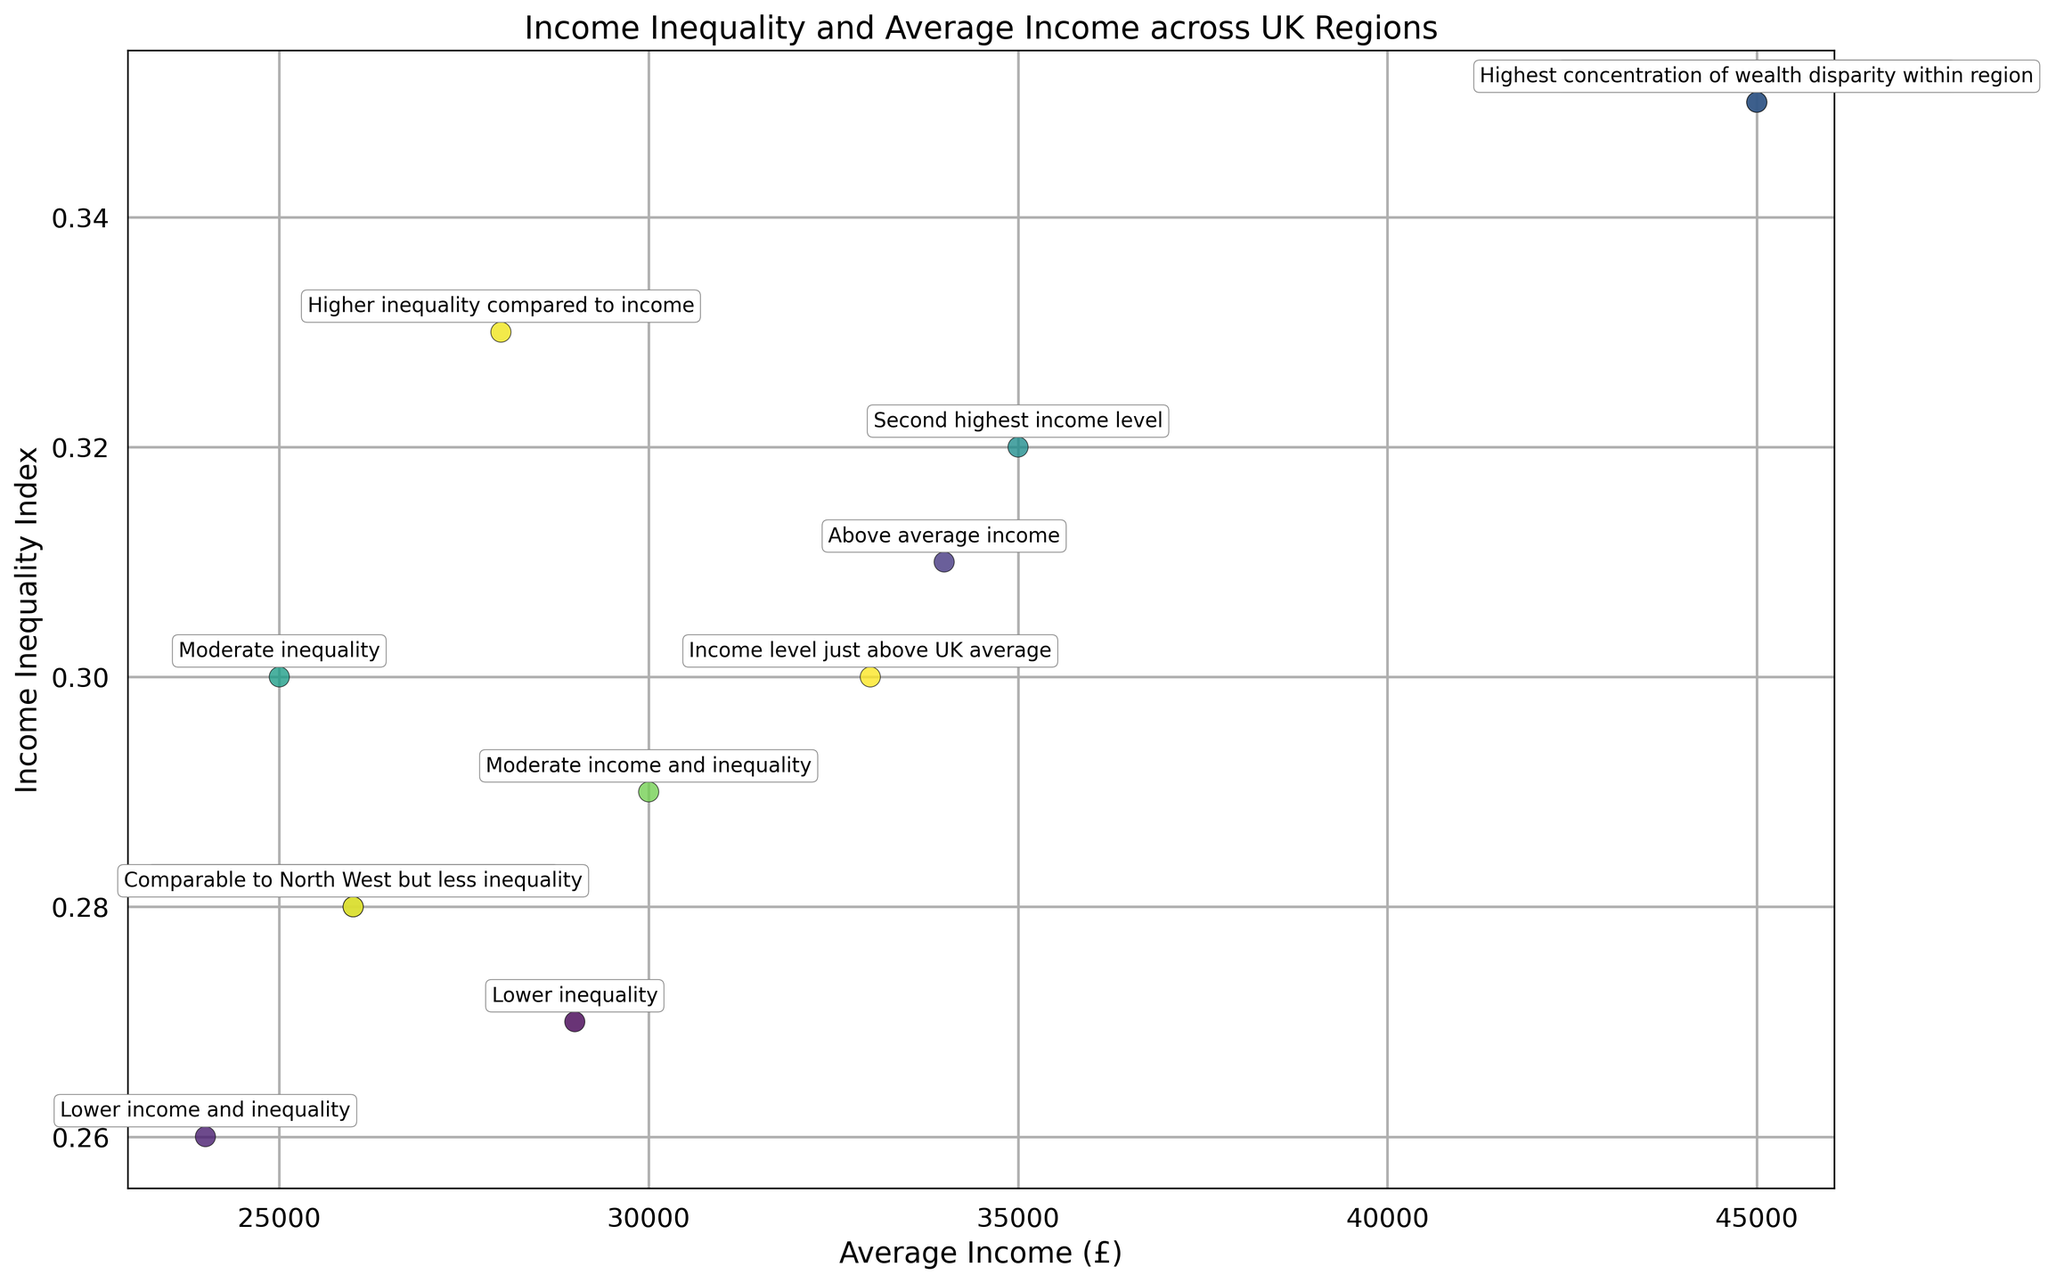Which region has the highest average income? From the scatter plot, we see that London has the highest average income, as annotated with "Highest income and income inequality."
Answer: London Which region has the lowest income inequality index? By examining the scatter plot and annotations, the North East has the lowest income inequality index with a value of 0.26 as noted with "Lower income and inequality."
Answer: North East Compare the average incomes of the South East and the East of England. Which one is higher and by how much? The South East has an average income of £35,000, while the East of England has £34,000. The difference is £35,000 - £34,000 = £1,000.
Answer: South East by £1,000 Is there a region with higher income but lower inequality than the South West? If so, which region? The South West has an average income of £33,000 and an income inequality index of 0.30. The East of England has a higher average income of £34,000 and a lower income inequality index of 0.31. However, the difference in inequality index is very small and not lower. No other region meets both criteria strictly.
Answer: No Which two regions have exactly the same average income and what is the amount? Both London Boroughs and London have an average income of £45,000 as noted in the annotations.
Answer: London and London Boroughs, £45,000 Which regions have an average income less than £30,000 and an income inequality index of 0.30 or more? Sorting through the scatter plot, the West Midlands (£28,000, 0.33) and Northern Ireland (£25,000, 0.30) meet these criteria.
Answer: West Midlands and Northern Ireland What is the difference in the income inequality index between Scotland and London Boroughs? Scotland has an income inequality index of 0.29, and London Boroughs have 0.35. The difference is 0.35 - 0.29 = 0.06.
Answer: 0.06 Which region with the second highest income level has what level of income inequality? The South East has the second highest income level of £35,000 and an income inequality index of 0.32 as per the annotations.
Answer: South East, 0.32 